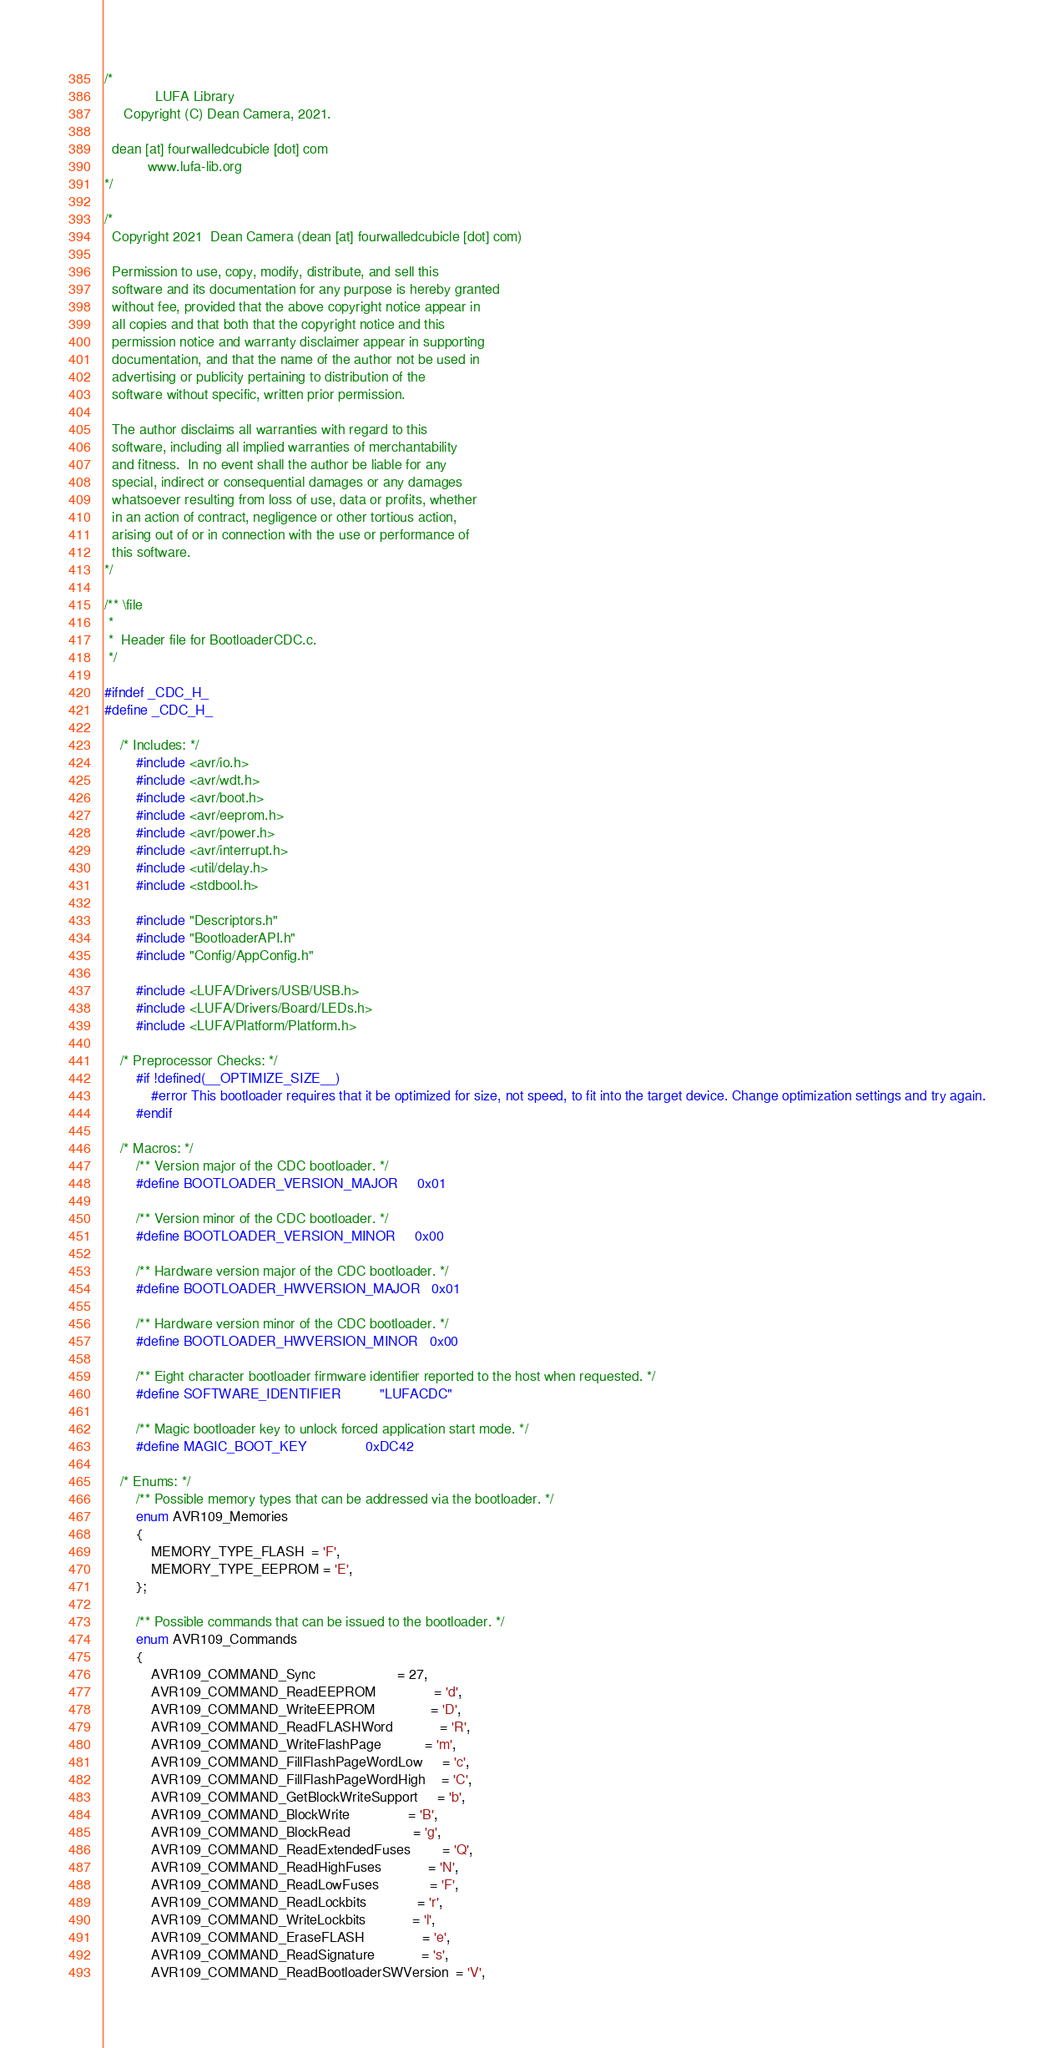Convert code to text. <code><loc_0><loc_0><loc_500><loc_500><_C_>/*
             LUFA Library
     Copyright (C) Dean Camera, 2021.

  dean [at] fourwalledcubicle [dot] com
           www.lufa-lib.org
*/

/*
  Copyright 2021  Dean Camera (dean [at] fourwalledcubicle [dot] com)

  Permission to use, copy, modify, distribute, and sell this
  software and its documentation for any purpose is hereby granted
  without fee, provided that the above copyright notice appear in
  all copies and that both that the copyright notice and this
  permission notice and warranty disclaimer appear in supporting
  documentation, and that the name of the author not be used in
  advertising or publicity pertaining to distribution of the
  software without specific, written prior permission.

  The author disclaims all warranties with regard to this
  software, including all implied warranties of merchantability
  and fitness.  In no event shall the author be liable for any
  special, indirect or consequential damages or any damages
  whatsoever resulting from loss of use, data or profits, whether
  in an action of contract, negligence or other tortious action,
  arising out of or in connection with the use or performance of
  this software.
*/

/** \file
 *
 *  Header file for BootloaderCDC.c.
 */

#ifndef _CDC_H_
#define _CDC_H_

	/* Includes: */
		#include <avr/io.h>
		#include <avr/wdt.h>
		#include <avr/boot.h>
		#include <avr/eeprom.h>
		#include <avr/power.h>
		#include <avr/interrupt.h>
		#include <util/delay.h>
		#include <stdbool.h>

		#include "Descriptors.h"
		#include "BootloaderAPI.h"
		#include "Config/AppConfig.h"

		#include <LUFA/Drivers/USB/USB.h>
		#include <LUFA/Drivers/Board/LEDs.h>
		#include <LUFA/Platform/Platform.h>

	/* Preprocessor Checks: */
		#if !defined(__OPTIMIZE_SIZE__)
			#error This bootloader requires that it be optimized for size, not speed, to fit into the target device. Change optimization settings and try again.
		#endif

	/* Macros: */
		/** Version major of the CDC bootloader. */
		#define BOOTLOADER_VERSION_MAJOR     0x01

		/** Version minor of the CDC bootloader. */
		#define BOOTLOADER_VERSION_MINOR     0x00

		/** Hardware version major of the CDC bootloader. */
		#define BOOTLOADER_HWVERSION_MAJOR   0x01

		/** Hardware version minor of the CDC bootloader. */
		#define BOOTLOADER_HWVERSION_MINOR   0x00

		/** Eight character bootloader firmware identifier reported to the host when requested. */
		#define SOFTWARE_IDENTIFIER          "LUFACDC"

		/** Magic bootloader key to unlock forced application start mode. */
		#define MAGIC_BOOT_KEY               0xDC42

	/* Enums: */
		/** Possible memory types that can be addressed via the bootloader. */
		enum AVR109_Memories
		{
			MEMORY_TYPE_FLASH  = 'F',
			MEMORY_TYPE_EEPROM = 'E',
		};

		/** Possible commands that can be issued to the bootloader. */
		enum AVR109_Commands
		{
			AVR109_COMMAND_Sync                     = 27,
			AVR109_COMMAND_ReadEEPROM               = 'd',
			AVR109_COMMAND_WriteEEPROM              = 'D',
			AVR109_COMMAND_ReadFLASHWord            = 'R',
			AVR109_COMMAND_WriteFlashPage           = 'm',
			AVR109_COMMAND_FillFlashPageWordLow     = 'c',
			AVR109_COMMAND_FillFlashPageWordHigh    = 'C',
			AVR109_COMMAND_GetBlockWriteSupport     = 'b',
			AVR109_COMMAND_BlockWrite               = 'B',
			AVR109_COMMAND_BlockRead                = 'g',
			AVR109_COMMAND_ReadExtendedFuses        = 'Q',
			AVR109_COMMAND_ReadHighFuses            = 'N',
			AVR109_COMMAND_ReadLowFuses             = 'F',
			AVR109_COMMAND_ReadLockbits             = 'r',
			AVR109_COMMAND_WriteLockbits            = 'l',
			AVR109_COMMAND_EraseFLASH               = 'e',
			AVR109_COMMAND_ReadSignature            = 's',
			AVR109_COMMAND_ReadBootloaderSWVersion  = 'V',</code> 